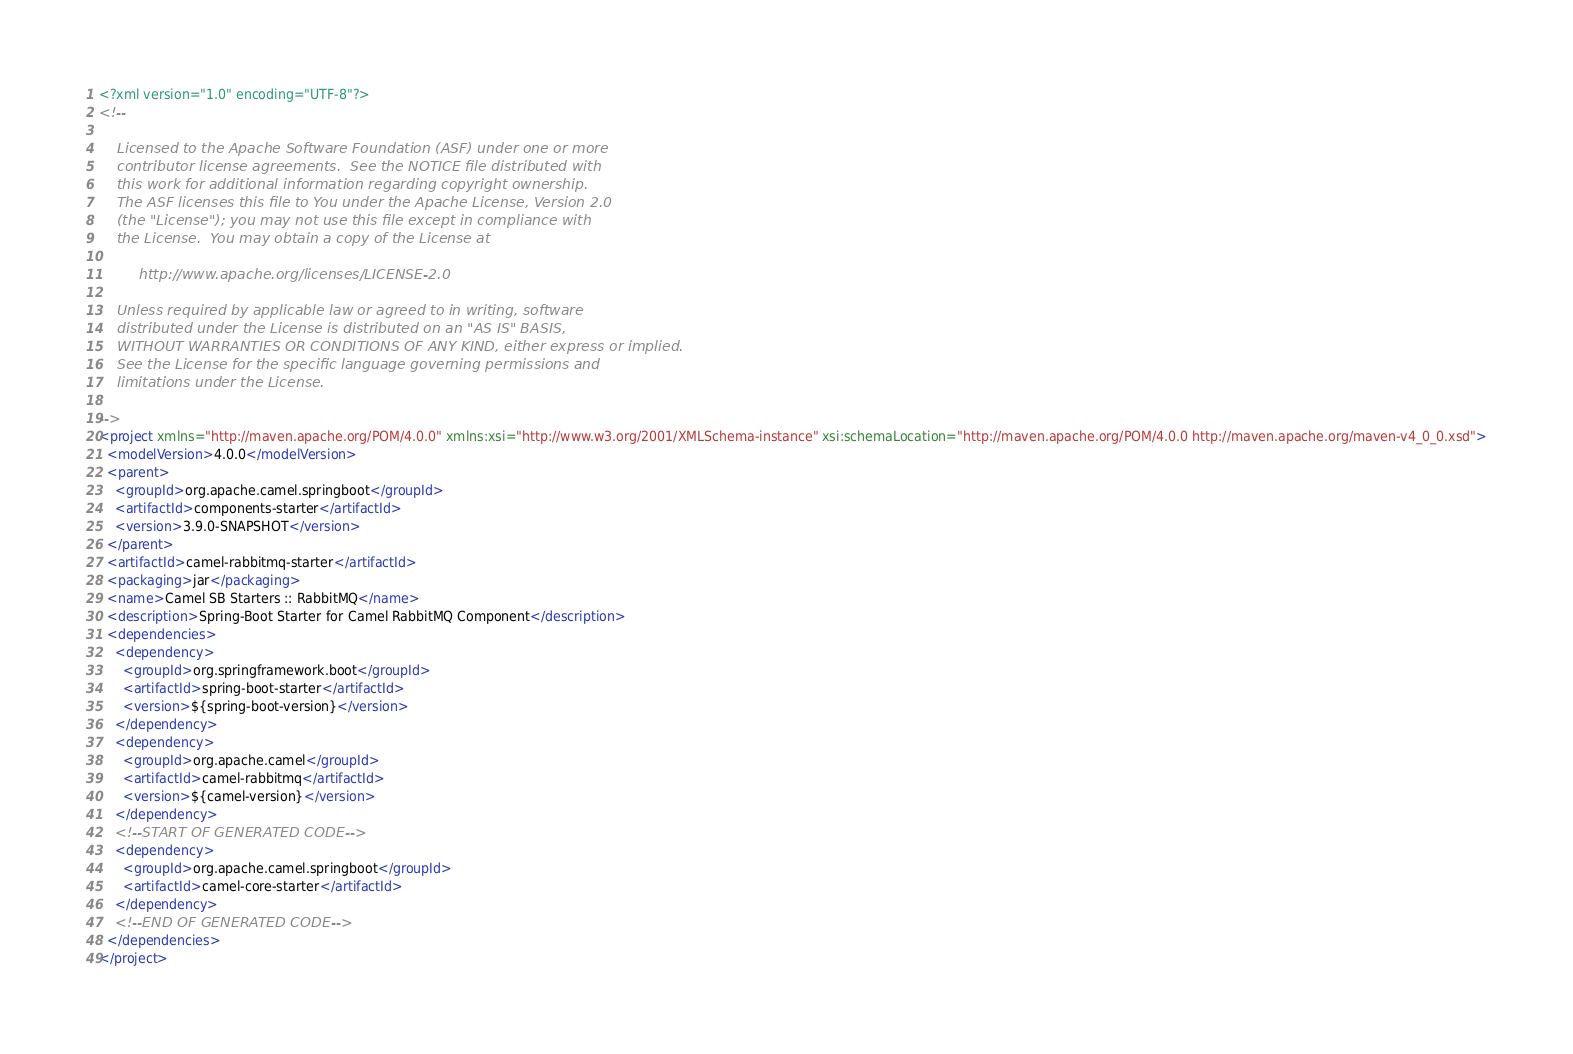Convert code to text. <code><loc_0><loc_0><loc_500><loc_500><_XML_><?xml version="1.0" encoding="UTF-8"?>
<!--

    Licensed to the Apache Software Foundation (ASF) under one or more
    contributor license agreements.  See the NOTICE file distributed with
    this work for additional information regarding copyright ownership.
    The ASF licenses this file to You under the Apache License, Version 2.0
    (the "License"); you may not use this file except in compliance with
    the License.  You may obtain a copy of the License at

         http://www.apache.org/licenses/LICENSE-2.0

    Unless required by applicable law or agreed to in writing, software
    distributed under the License is distributed on an "AS IS" BASIS,
    WITHOUT WARRANTIES OR CONDITIONS OF ANY KIND, either express or implied.
    See the License for the specific language governing permissions and
    limitations under the License.

-->
<project xmlns="http://maven.apache.org/POM/4.0.0" xmlns:xsi="http://www.w3.org/2001/XMLSchema-instance" xsi:schemaLocation="http://maven.apache.org/POM/4.0.0 http://maven.apache.org/maven-v4_0_0.xsd">
  <modelVersion>4.0.0</modelVersion>
  <parent>
    <groupId>org.apache.camel.springboot</groupId>
    <artifactId>components-starter</artifactId>
    <version>3.9.0-SNAPSHOT</version>
  </parent>
  <artifactId>camel-rabbitmq-starter</artifactId>
  <packaging>jar</packaging>
  <name>Camel SB Starters :: RabbitMQ</name>
  <description>Spring-Boot Starter for Camel RabbitMQ Component</description>
  <dependencies>
    <dependency>
      <groupId>org.springframework.boot</groupId>
      <artifactId>spring-boot-starter</artifactId>
      <version>${spring-boot-version}</version>
    </dependency>
    <dependency>
      <groupId>org.apache.camel</groupId>
      <artifactId>camel-rabbitmq</artifactId>
      <version>${camel-version}</version>
    </dependency>
    <!--START OF GENERATED CODE-->
    <dependency>
      <groupId>org.apache.camel.springboot</groupId>
      <artifactId>camel-core-starter</artifactId>
    </dependency>
    <!--END OF GENERATED CODE-->
  </dependencies>
</project>
</code> 